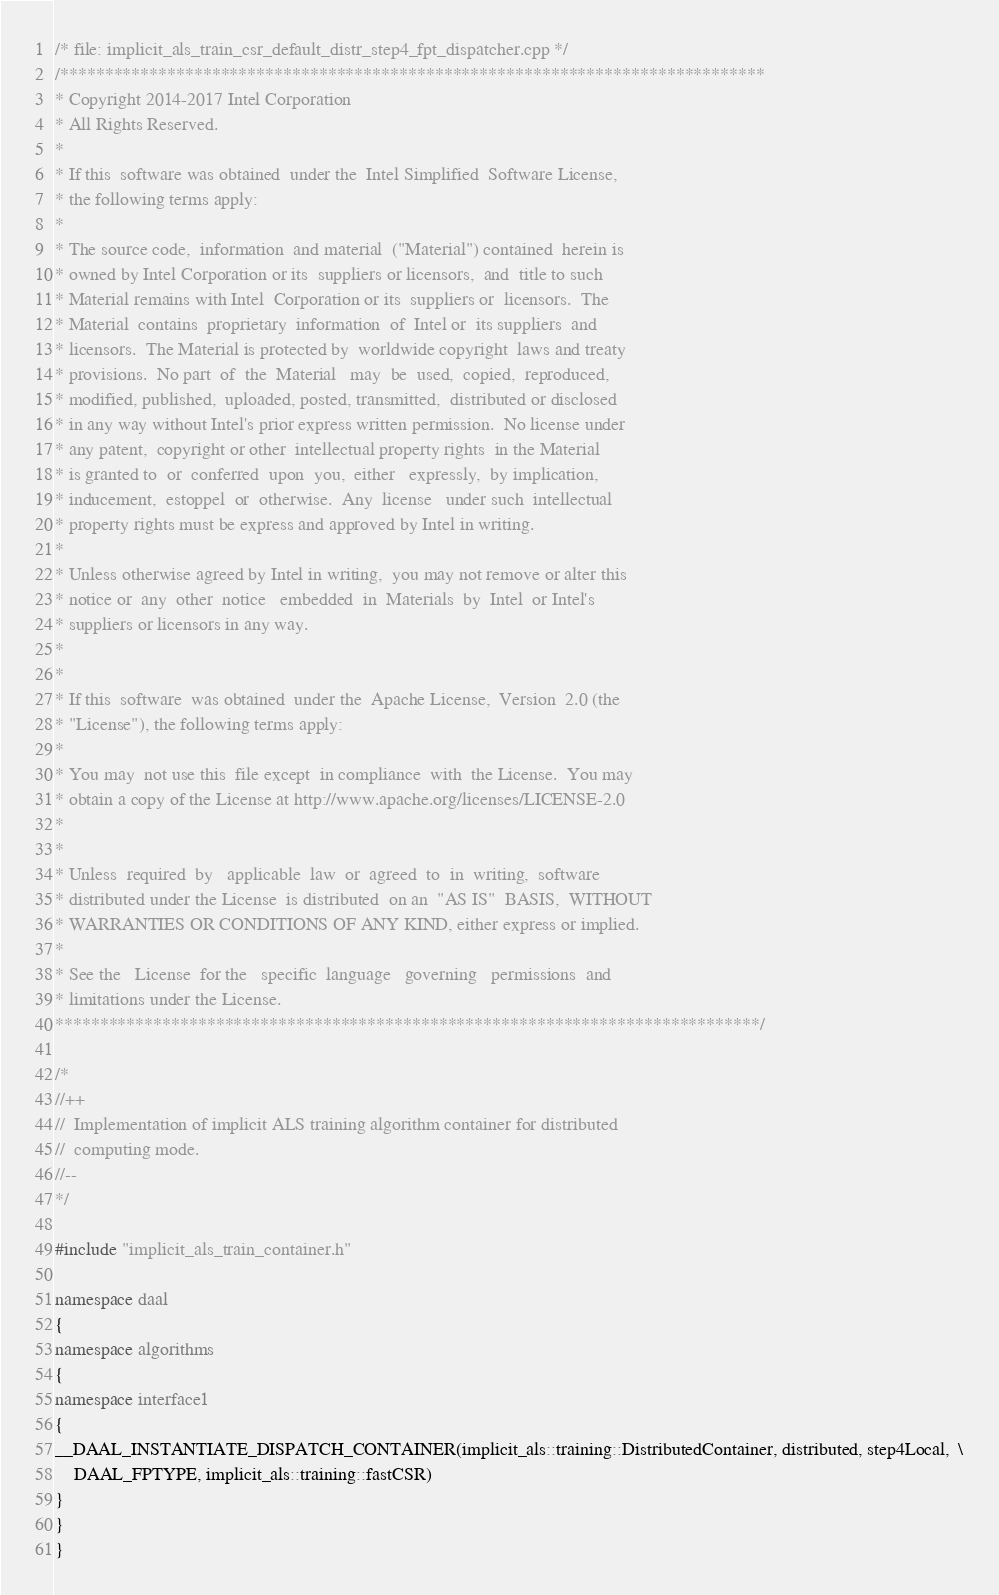Convert code to text. <code><loc_0><loc_0><loc_500><loc_500><_C++_>/* file: implicit_als_train_csr_default_distr_step4_fpt_dispatcher.cpp */
/*******************************************************************************
* Copyright 2014-2017 Intel Corporation
* All Rights Reserved.
*
* If this  software was obtained  under the  Intel Simplified  Software License,
* the following terms apply:
*
* The source code,  information  and material  ("Material") contained  herein is
* owned by Intel Corporation or its  suppliers or licensors,  and  title to such
* Material remains with Intel  Corporation or its  suppliers or  licensors.  The
* Material  contains  proprietary  information  of  Intel or  its suppliers  and
* licensors.  The Material is protected by  worldwide copyright  laws and treaty
* provisions.  No part  of  the  Material   may  be  used,  copied,  reproduced,
* modified, published,  uploaded, posted, transmitted,  distributed or disclosed
* in any way without Intel's prior express written permission.  No license under
* any patent,  copyright or other  intellectual property rights  in the Material
* is granted to  or  conferred  upon  you,  either   expressly,  by implication,
* inducement,  estoppel  or  otherwise.  Any  license   under such  intellectual
* property rights must be express and approved by Intel in writing.
*
* Unless otherwise agreed by Intel in writing,  you may not remove or alter this
* notice or  any  other  notice   embedded  in  Materials  by  Intel  or Intel's
* suppliers or licensors in any way.
*
*
* If this  software  was obtained  under the  Apache License,  Version  2.0 (the
* "License"), the following terms apply:
*
* You may  not use this  file except  in compliance  with  the License.  You may
* obtain a copy of the License at http://www.apache.org/licenses/LICENSE-2.0
*
*
* Unless  required  by   applicable  law  or  agreed  to  in  writing,  software
* distributed under the License  is distributed  on an  "AS IS"  BASIS,  WITHOUT
* WARRANTIES OR CONDITIONS OF ANY KIND, either express or implied.
*
* See the   License  for the   specific  language   governing   permissions  and
* limitations under the License.
*******************************************************************************/

/*
//++
//  Implementation of implicit ALS training algorithm container for distributed
//  computing mode.
//--
*/

#include "implicit_als_train_container.h"

namespace daal
{
namespace algorithms
{
namespace interface1
{
__DAAL_INSTANTIATE_DISPATCH_CONTAINER(implicit_als::training::DistributedContainer, distributed, step4Local,  \
    DAAL_FPTYPE, implicit_als::training::fastCSR)
}
}
}
</code> 